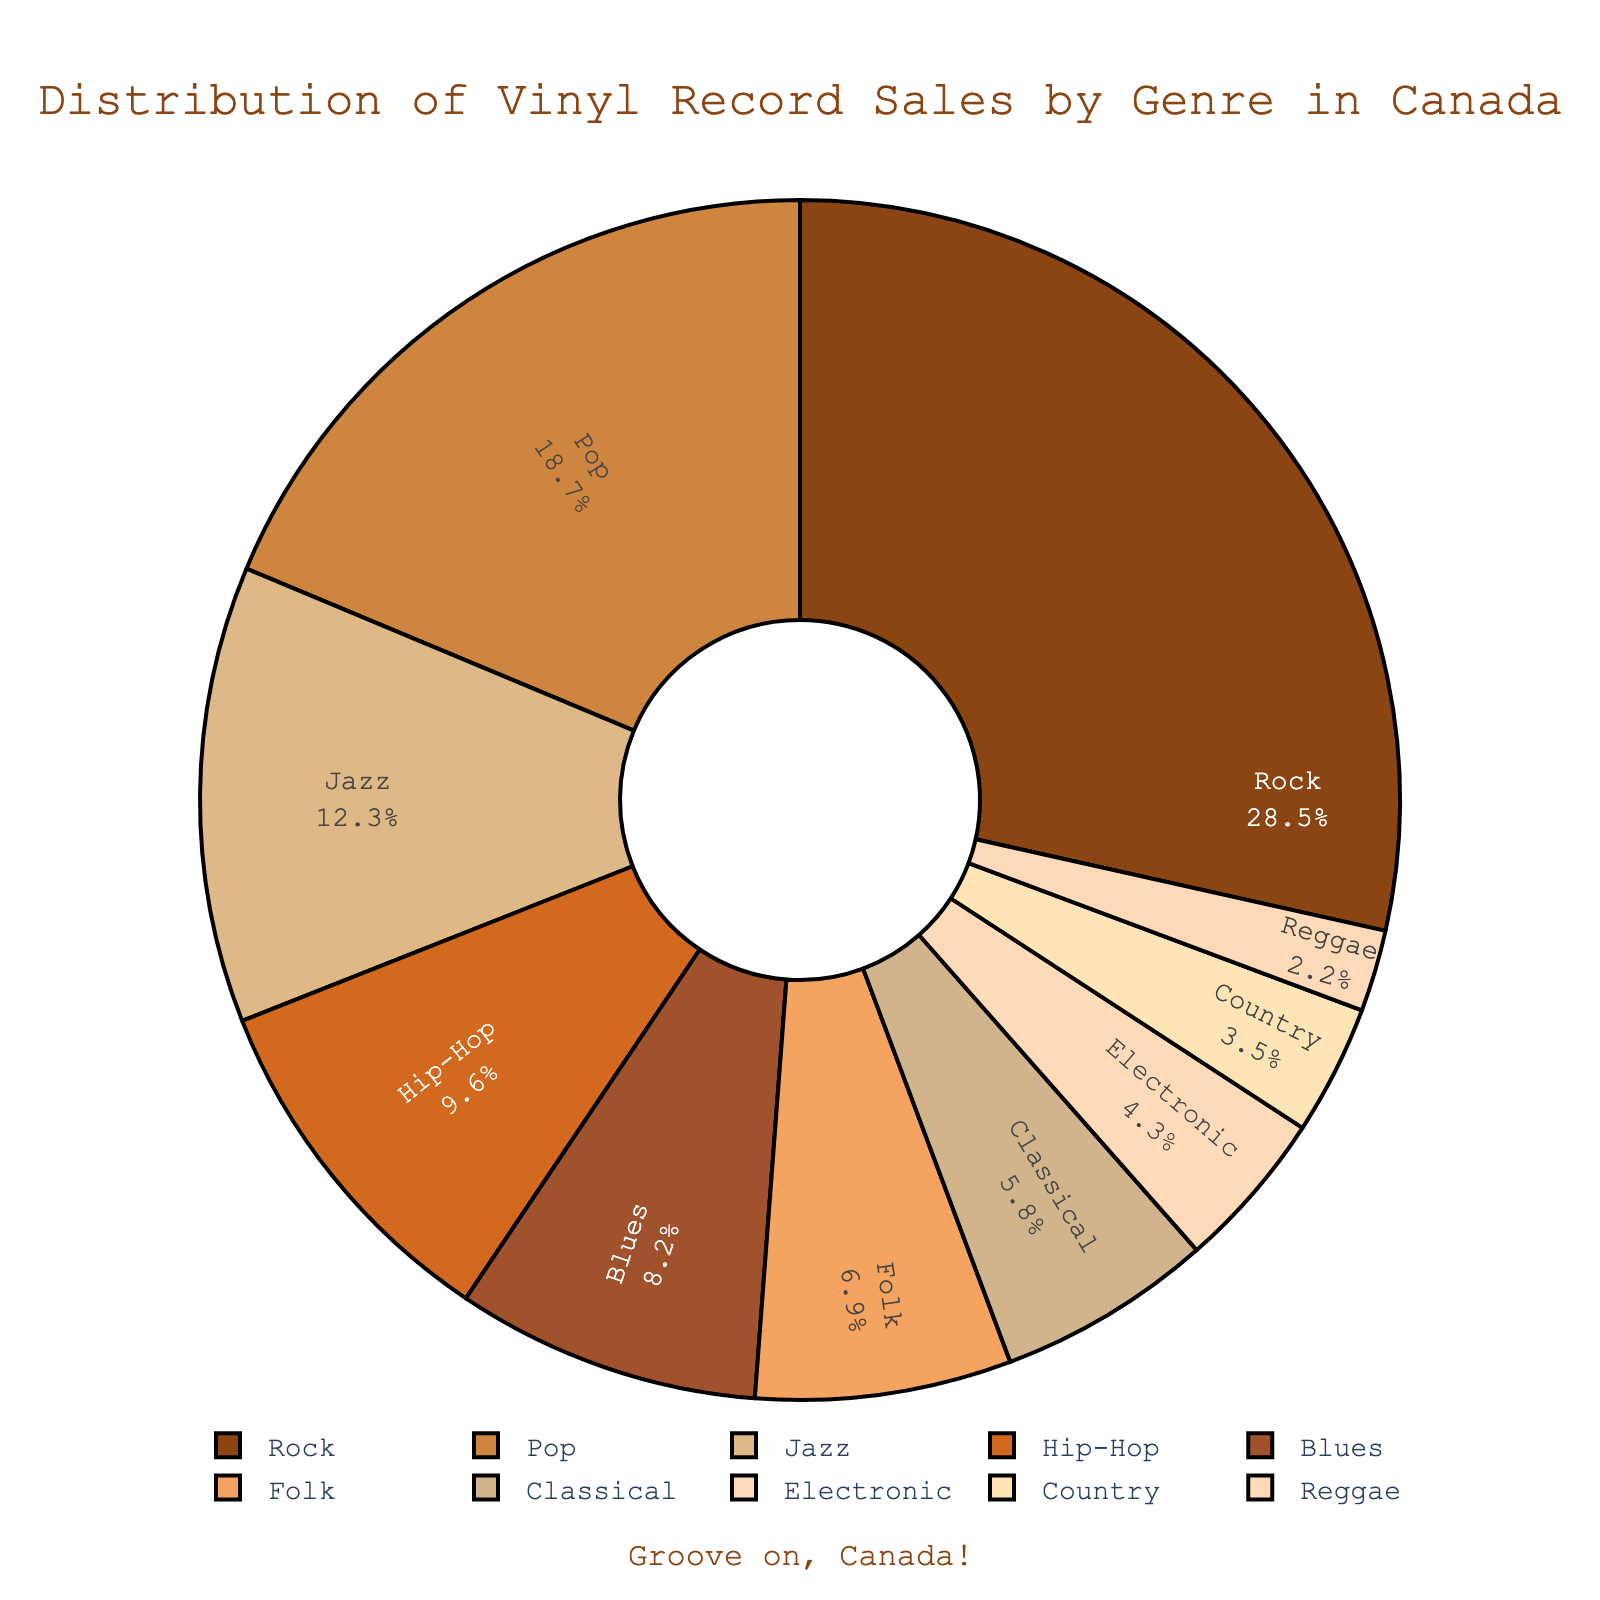Which genre has the highest percentage of vinyl record sales in Canada? The figure shows different genres and their corresponding sales percentages. The Rock genre has the largest slice.
Answer: Rock What is the combined percentage of vinyl record sales for Jazz and Blues? According to the chart, Jazz accounts for 12.3% and Blues for 8.2%. Adding these together gives 12.3% + 8.2% = 20.5%.
Answer: 20.5% How much higher is the percentage of Rock vinyl sales than Country? Rock has 28.5% and Country has 3.5%. The difference is 28.5% - 3.5% = 25%.
Answer: 25% Which genres have a sales percentage less than 10% but more than 5%? Checking the figure, the genres that fall within the 5%-10% range are Hip-Hop, Blues, Folk, and Classical.
Answer: Hip-Hop, Blues, Folk, Classical Is the percentage of Pop vinyl record sales more than double that of Classical? Pop has 18.7%, and Classical has 5.8%. Doubling 5.8% gives 11.6%, which is less than 18.7%. Hence, Pop’s percentage is more than double that of Classical.
Answer: Yes How does the percentage of Blues compare to Electronic? Blues has 8.2%, and Electronic has 4.3%. Blues has a higher percentage than Electronic.
Answer: Blues has a higher percentage What is the total percentage of sales for the top three genres? The top three genres are Rock (28.5%), Pop (18.7%), and Jazz (12.3%). Adding these gives 28.5% + 18.7% + 12.3% = 59.5%.
Answer: 59.5% Between Folk and Reggae, which genre has a smaller percentage of vinyl record sales, and by how much? Folk has 6.9% and Reggae has 2.2%. The difference is 6.9% - 2.2% = 4.7%. Reggae has the smaller percentage.
Answer: Reggae, by 4.7% Which genre’s percentage is closest to the average percentage of all genres? The total percentage is 100%, and there are 10 genres. The average is 100% / 10 = 10%. Looking at the values, Hip-Hop at 9.6% is closest to 10%.
Answer: Hip-Hop What is the difference in sales percentage between the genres with the fifth and the sixth highest percentages? The fifth highest percentage is Blues with 8.2% and the sixth is Folk with 6.9%. The difference is 8.2% - 6.9% = 1.3%.
Answer: 1.3% 